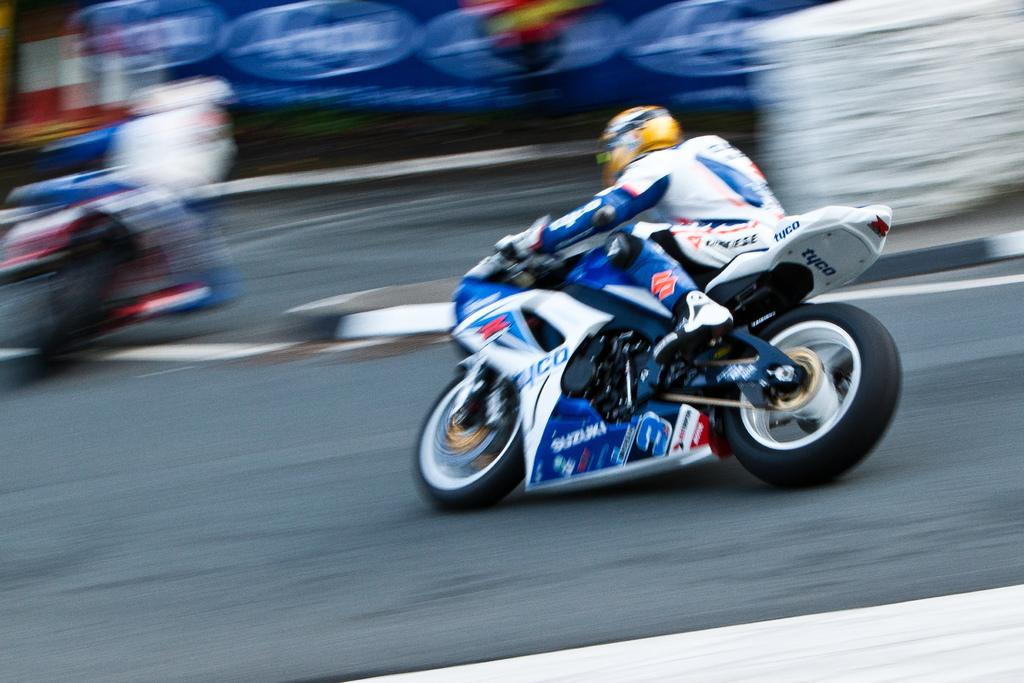What is the main subject in the center of the image? There is a bike in the center of the image. What is the person on the bike doing? The person is sitting on the bike and riding it. How would you describe the background of the image? The background of the image is blurry. What can be seen at the bottom of the image? There is a road at the bottom of the image. Can you tell me how many goldfish are swimming in the club in the image? There are no goldfish or clubs present in the image. 